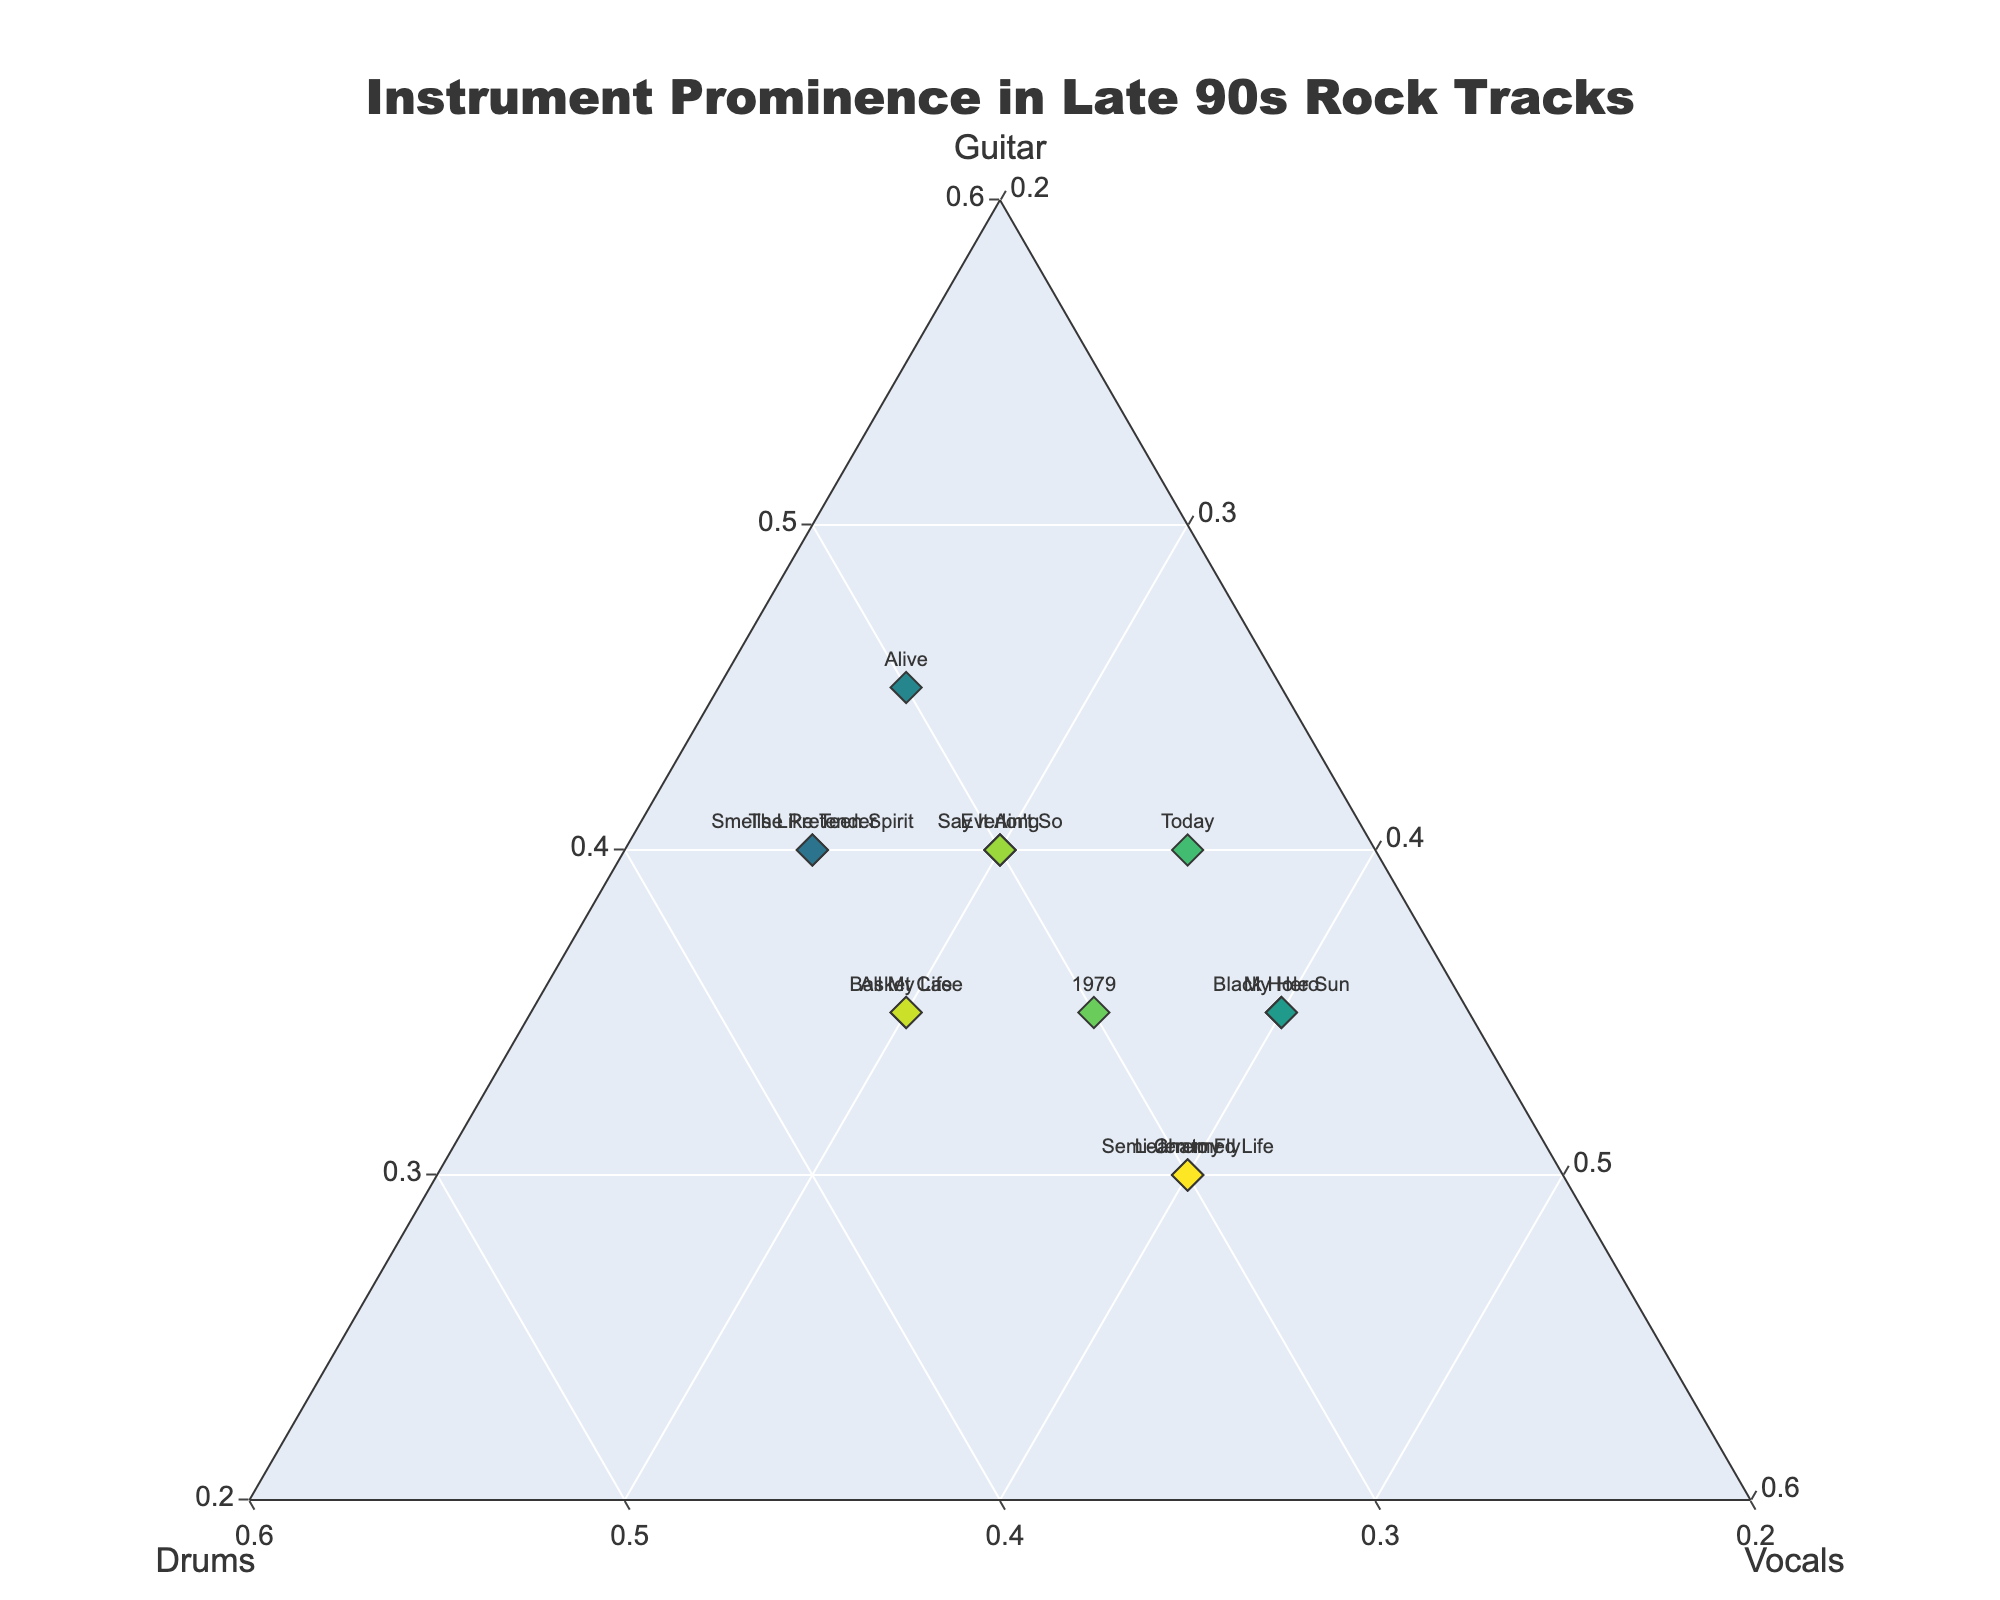What is the title of the ternary plot? At the top of the plot, the title is displayed. It is in a larger and bold font to make it easily noticeable.
Answer: Instrument Prominence in Late 90s Rock Tracks Which song has the highest vocal prominence? Look for the data point closest to the vertex labeled 'Vocals'.
Answer: Semi-Charmed Life Are there any songs with equal prominence for all three instruments? Check if any data point is perfectly centered on the plot, corresponding to equal prominence of 0.33 for each instrument.
Answer: No How do the instrument prominences compare for "Everlong" and "Basket Case"? Check the positions of "Everlong" and "Basket Case" relative to the three vertices. "Everlong" has equal prominence for Drums and Vocals (both 0.3) and slightly higher for Guitar (0.4), while "Basket Case" has equal prominence for Guitar and Drums (both 0.35) and slightly lower for Vocals (0.3).
Answer: Everlong: Guitar > Drums = Vocals; Basket Case: Guitar = Drums > Vocals Which songs have the same guitar prominence? Find data points along the same line parallel to the side opposite the 'Guitar' vertex.
Answer: Everlong, The Pretender, Smells Like Teen Spirit, Today, Say It Ain't So Which song has the lowest drum prominence? Locate the point closest to the vertex labeled 'Vocals' because a lower drum prominence will push the point upwards towards Vocals. Check exact values to identify the lowest.
Answer: My Hero Calculate the average guitar prominence for the songs "Jeremy", "Alive", and "Today". Sum the guitar prominences for the three songs and divide by 3. (0.3 for Jeremy + 0.45 for Alive + 0.4 for Today) / 3 = 1.15 / 3.
Answer: 0.3833 For the song "Learn to Fly", what is the difference between the prominence of vocals and guitar? Subtract the guitar prominence (0.3) from the vocal prominence (0.4). 0.4 - 0.3 = 0.1
Answer: 0.1 Which song features the most balanced prominence between drums and guitar? Find the data points where the coordinates for drums and guitar are closest to each other.
Answer: All My Life Is there any song with a drums prominence of 0.3 that has a vocal prominence higher than 0.35? Check the data points where drums = 0.3 and compare vocal prominence values to see if any are > 0.35.
Answer: Semi-Charmed Life, Jeremy, Learn to Fly 